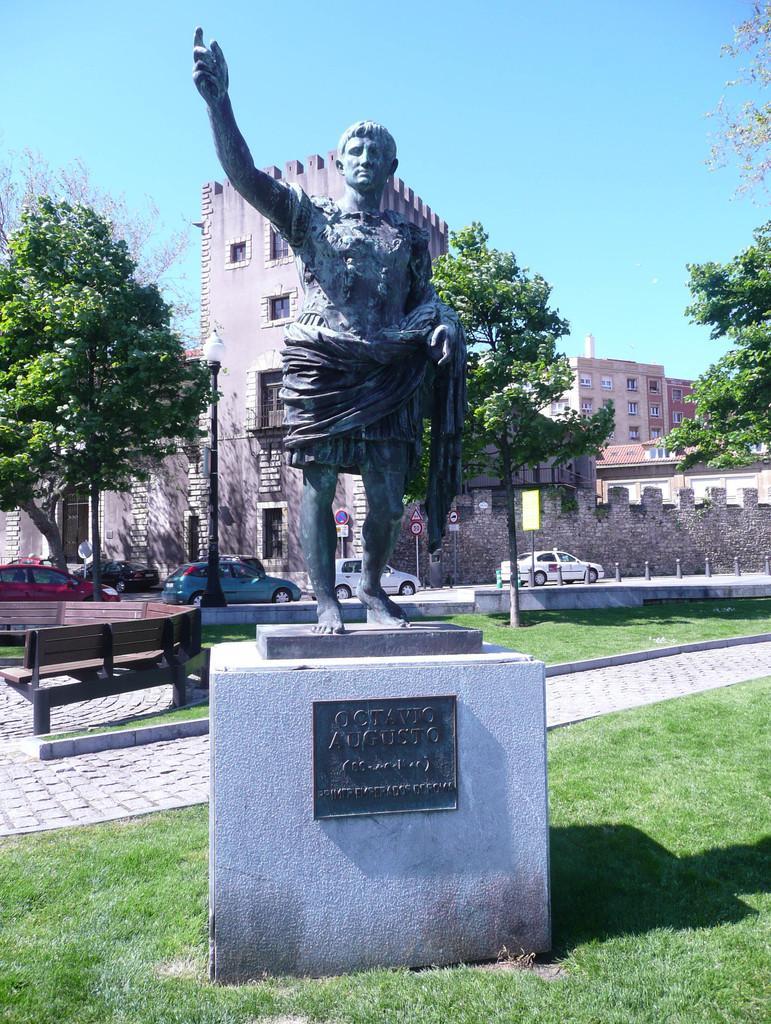Describe this image in one or two sentences. In the center of the image there is a statue on the grass. In the background we can see benches, trees, vehicles, roads, sign boards and sky. 